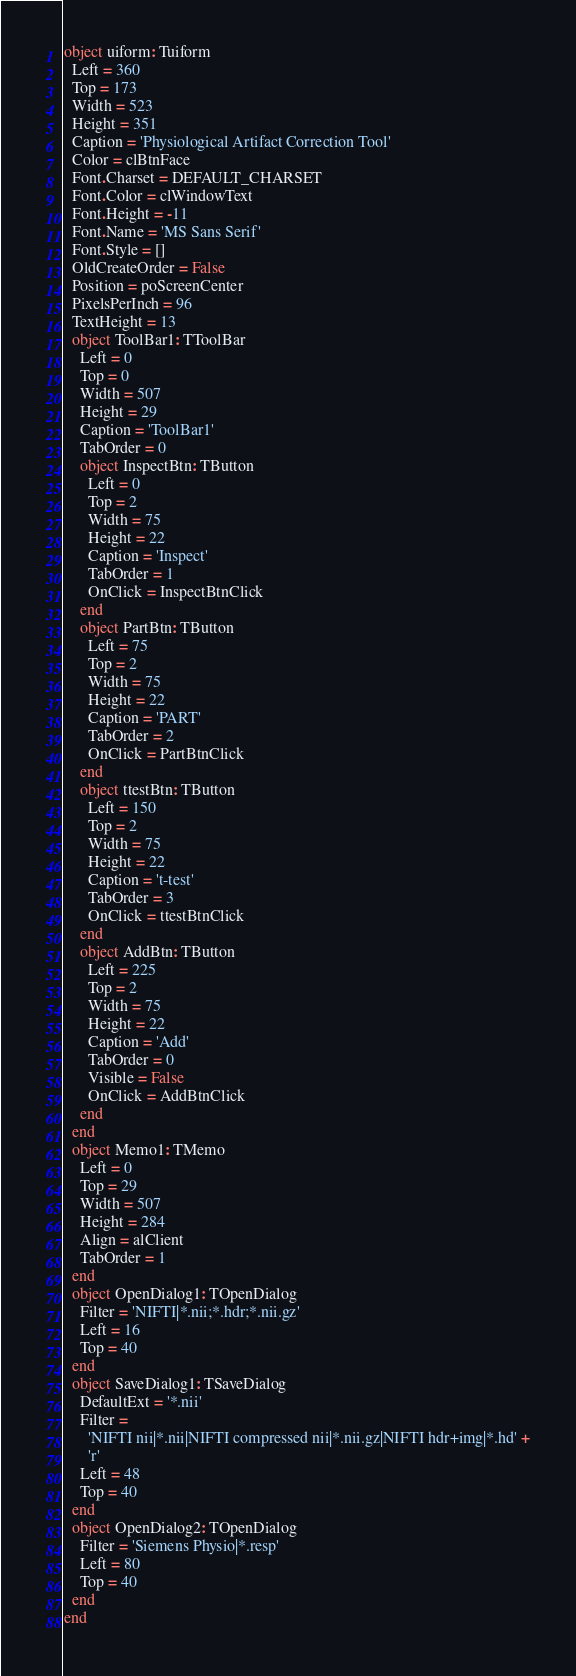<code> <loc_0><loc_0><loc_500><loc_500><_Pascal_>object uiform: Tuiform
  Left = 360
  Top = 173
  Width = 523
  Height = 351
  Caption = 'Physiological Artifact Correction Tool'
  Color = clBtnFace
  Font.Charset = DEFAULT_CHARSET
  Font.Color = clWindowText
  Font.Height = -11
  Font.Name = 'MS Sans Serif'
  Font.Style = []
  OldCreateOrder = False
  Position = poScreenCenter
  PixelsPerInch = 96
  TextHeight = 13
  object ToolBar1: TToolBar
    Left = 0
    Top = 0
    Width = 507
    Height = 29
    Caption = 'ToolBar1'
    TabOrder = 0
    object InspectBtn: TButton
      Left = 0
      Top = 2
      Width = 75
      Height = 22
      Caption = 'Inspect'
      TabOrder = 1
      OnClick = InspectBtnClick
    end
    object PartBtn: TButton
      Left = 75
      Top = 2
      Width = 75
      Height = 22
      Caption = 'PART'
      TabOrder = 2
      OnClick = PartBtnClick
    end
    object ttestBtn: TButton
      Left = 150
      Top = 2
      Width = 75
      Height = 22
      Caption = 't-test'
      TabOrder = 3
      OnClick = ttestBtnClick
    end
    object AddBtn: TButton
      Left = 225
      Top = 2
      Width = 75
      Height = 22
      Caption = 'Add'
      TabOrder = 0
      Visible = False
      OnClick = AddBtnClick
    end
  end
  object Memo1: TMemo
    Left = 0
    Top = 29
    Width = 507
    Height = 284
    Align = alClient
    TabOrder = 1
  end
  object OpenDialog1: TOpenDialog
    Filter = 'NIFTI|*.nii;*.hdr;*.nii.gz'
    Left = 16
    Top = 40
  end
  object SaveDialog1: TSaveDialog
    DefaultExt = '*.nii'
    Filter = 
      'NIFTI nii|*.nii|NIFTI compressed nii|*.nii.gz|NIFTI hdr+img|*.hd' +
      'r'
    Left = 48
    Top = 40
  end
  object OpenDialog2: TOpenDialog
    Filter = 'Siemens Physio|*.resp'
    Left = 80
    Top = 40
  end
end
</code> 